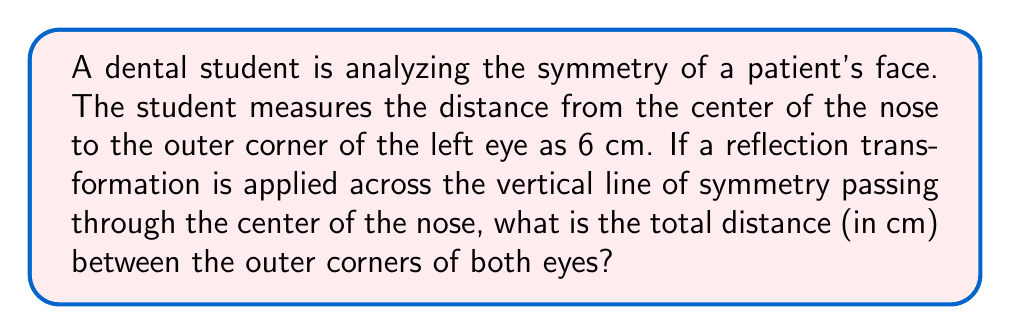Teach me how to tackle this problem. Let's approach this step-by-step:

1) The vertical line passing through the center of the nose acts as the line of symmetry for the face.

2) The given distance from the center of the nose to the outer corner of the left eye is 6 cm.

3) A reflection transformation across the line of symmetry will create a mirror image on the right side of the face.

4) Therefore, the distance from the center of the nose to the outer corner of the right eye will also be 6 cm.

5) To find the total distance between the outer corners of both eyes, we need to add these two distances:

   $$\text{Total distance} = \text{Left distance} + \text{Right distance}$$
   $$\text{Total distance} = 6 \text{ cm} + 6 \text{ cm} = 12 \text{ cm}$$

6) Thus, the total distance between the outer corners of both eyes is 12 cm.

[asy]
import geometry;

size(200);

pair A = (-3,0), B = (0,0), C = (3,0);
dot(A); dot(B); dot(C);

draw(A--C);
draw((0,-1)--(0,1), dashed);

label("Left eye", A, SW);
label("Nose", B, S);
label("Right eye", C, SE);

label("6 cm", (A+B)/2, N);
label("6 cm", (B+C)/2, N);
[/asy]
Answer: 12 cm 